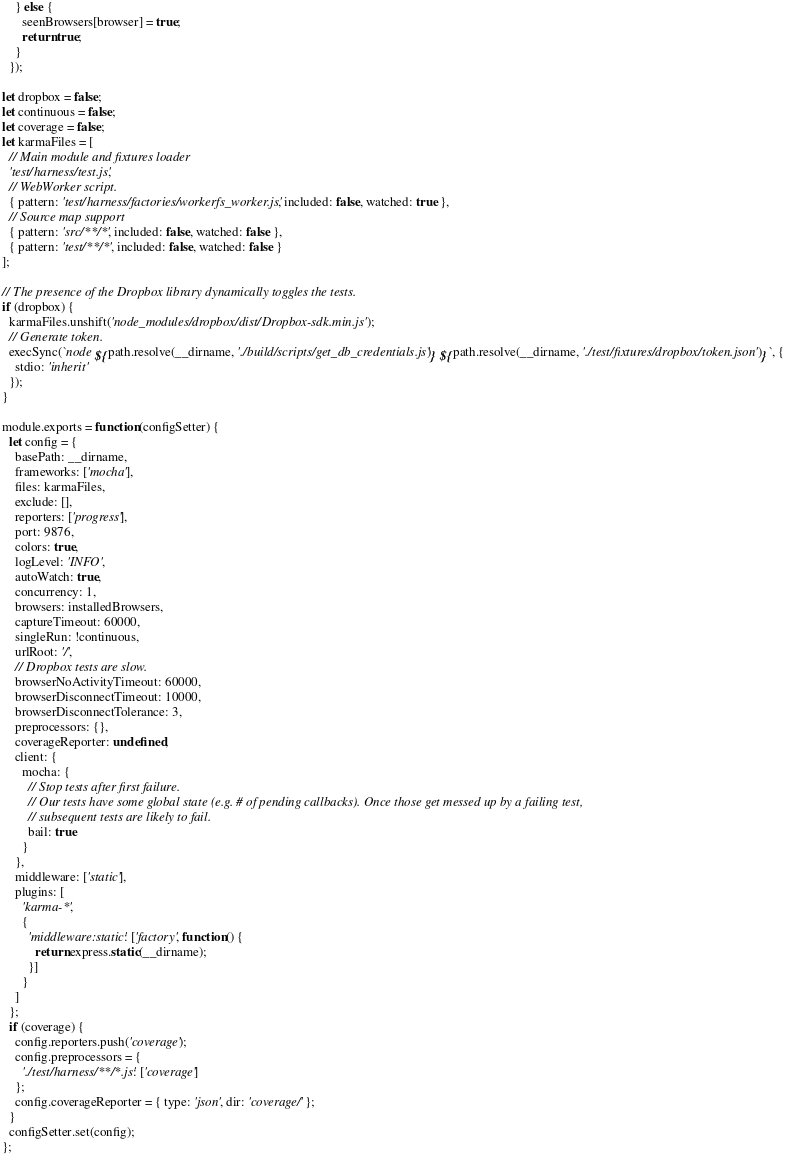Convert code to text. <code><loc_0><loc_0><loc_500><loc_500><_JavaScript_>    } else {
      seenBrowsers[browser] = true;
      return true;
    }
  });

let dropbox = false;
let continuous = false;
let coverage = false;
let karmaFiles = [
  // Main module and fixtures loader
  'test/harness/test.js',
  // WebWorker script.
  { pattern: 'test/harness/factories/workerfs_worker.js', included: false, watched: true },
  // Source map support
  { pattern: 'src/**/*', included: false, watched: false },
  { pattern: 'test/**/*', included: false, watched: false }
];

// The presence of the Dropbox library dynamically toggles the tests.
if (dropbox) {
  karmaFiles.unshift('node_modules/dropbox/dist/Dropbox-sdk.min.js');
  // Generate token.
  execSync(`node ${path.resolve(__dirname, './build/scripts/get_db_credentials.js')} ${path.resolve(__dirname, './test/fixtures/dropbox/token.json')}`, {
    stdio: 'inherit'
  });
}

module.exports = function(configSetter) {
  let config = {
    basePath: __dirname,
    frameworks: ['mocha'],
    files: karmaFiles,
    exclude: [],
    reporters: ['progress'],
    port: 9876,
    colors: true,
    logLevel: 'INFO',
    autoWatch: true,
    concurrency: 1,
    browsers: installedBrowsers,
    captureTimeout: 60000,
    singleRun: !continuous,
    urlRoot: '/',
    // Dropbox tests are slow.
    browserNoActivityTimeout: 60000,
    browserDisconnectTimeout: 10000,
    browserDisconnectTolerance: 3,
    preprocessors: {},
    coverageReporter: undefined,
    client: {
      mocha: {
        // Stop tests after first failure.
        // Our tests have some global state (e.g. # of pending callbacks). Once those get messed up by a failing test,
        // subsequent tests are likely to fail.
        bail: true
      }
    },
    middleware: ['static'],
    plugins: [
      'karma-*',
      {
        'middleware:static': ['factory', function() {
          return express.static(__dirname);
        }]
      }
    ]
  };
  if (coverage) {
    config.reporters.push('coverage');
    config.preprocessors = {
      './test/harness/**/*.js': ['coverage']
    };
    config.coverageReporter = { type: 'json', dir: 'coverage/' };
  }
  configSetter.set(config);
};
</code> 